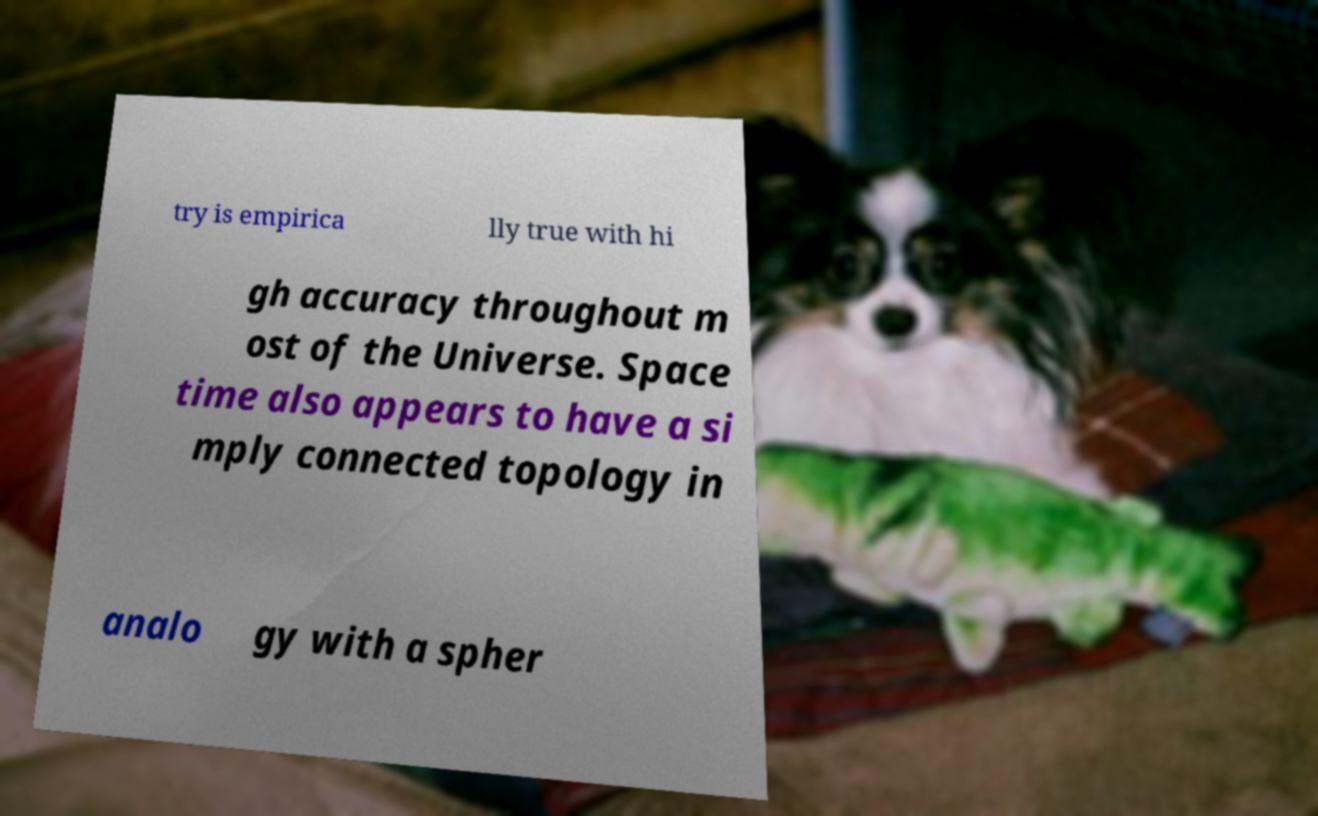Can you read and provide the text displayed in the image?This photo seems to have some interesting text. Can you extract and type it out for me? try is empirica lly true with hi gh accuracy throughout m ost of the Universe. Space time also appears to have a si mply connected topology in analo gy with a spher 